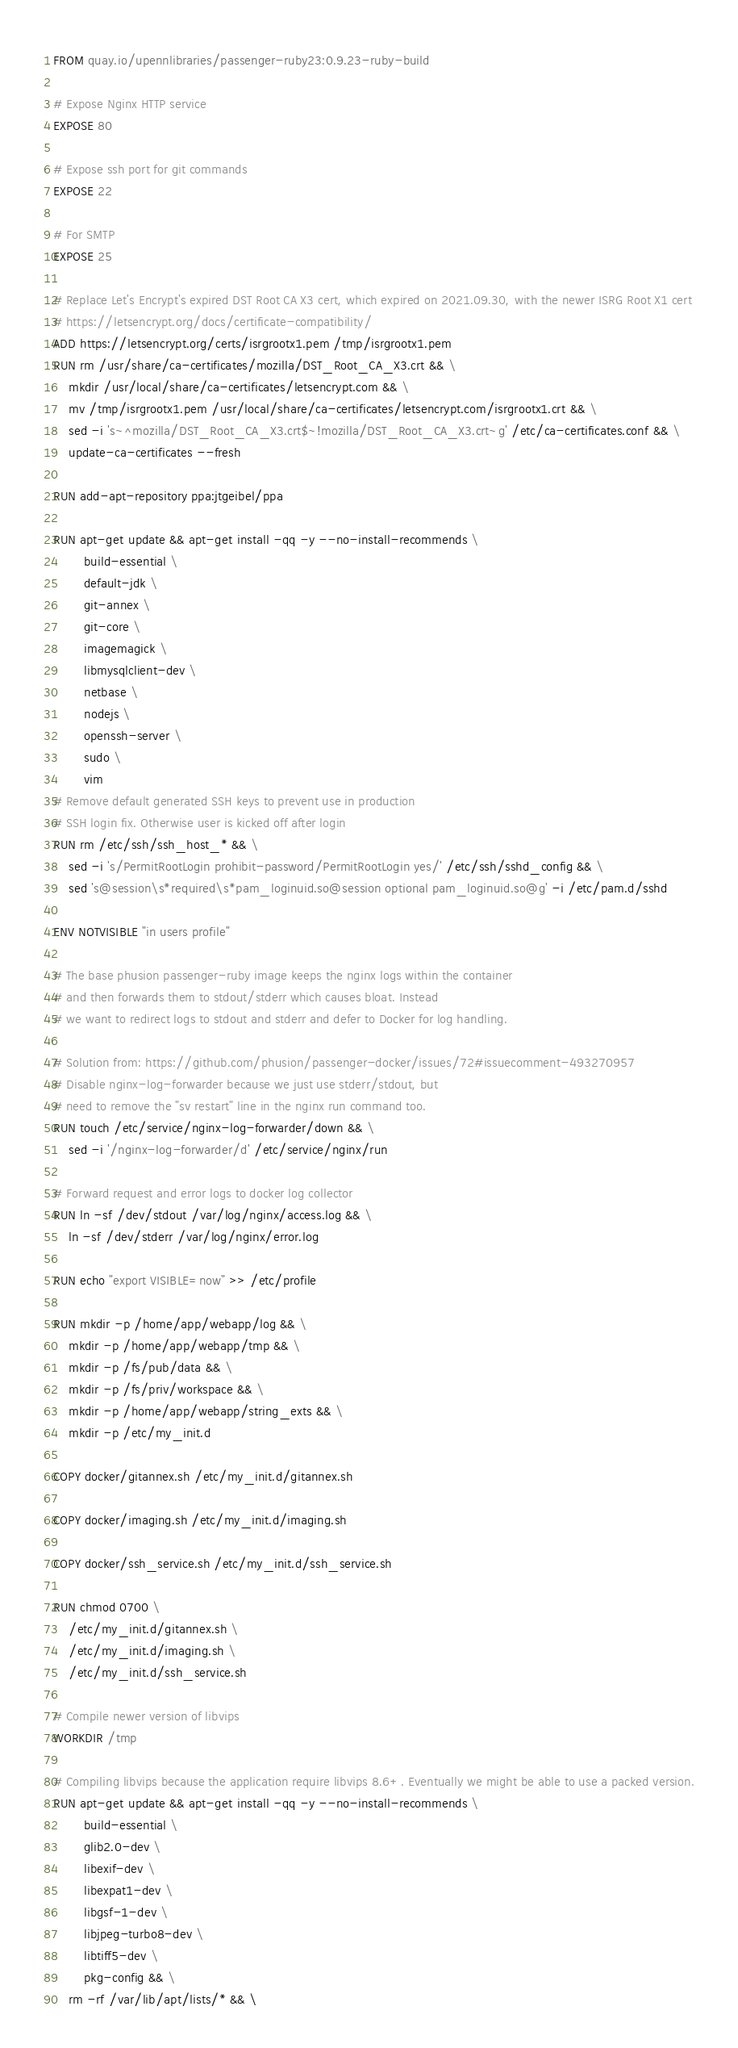Convert code to text. <code><loc_0><loc_0><loc_500><loc_500><_Dockerfile_>FROM quay.io/upennlibraries/passenger-ruby23:0.9.23-ruby-build

# Expose Nginx HTTP service
EXPOSE 80

# Expose ssh port for git commands
EXPOSE 22

# For SMTP
EXPOSE 25

# Replace Let's Encrypt's expired DST Root CA X3 cert, which expired on 2021.09.30, with the newer ISRG Root X1 cert
# https://letsencrypt.org/docs/certificate-compatibility/
ADD https://letsencrypt.org/certs/isrgrootx1.pem /tmp/isrgrootx1.pem
RUN rm /usr/share/ca-certificates/mozilla/DST_Root_CA_X3.crt && \
    mkdir /usr/local/share/ca-certificates/letsencrypt.com && \
    mv /tmp/isrgrootx1.pem /usr/local/share/ca-certificates/letsencrypt.com/isrgrootx1.crt && \
    sed -i 's~^mozilla/DST_Root_CA_X3.crt$~!mozilla/DST_Root_CA_X3.crt~g' /etc/ca-certificates.conf && \
    update-ca-certificates --fresh

RUN add-apt-repository ppa:jtgeibel/ppa

RUN apt-get update && apt-get install -qq -y --no-install-recommends \
        build-essential \
        default-jdk \
        git-annex \
        git-core \
        imagemagick \
        libmysqlclient-dev \
        netbase \
        nodejs \
        openssh-server \
        sudo \
        vim
# Remove default generated SSH keys to prevent use in production
# SSH login fix. Otherwise user is kicked off after login
RUN rm /etc/ssh/ssh_host_* && \
    sed -i 's/PermitRootLogin prohibit-password/PermitRootLogin yes/' /etc/ssh/sshd_config && \
    sed 's@session\s*required\s*pam_loginuid.so@session optional pam_loginuid.so@g' -i /etc/pam.d/sshd

ENV NOTVISIBLE "in users profile"

# The base phusion passenger-ruby image keeps the nginx logs within the container
# and then forwards them to stdout/stderr which causes bloat. Instead
# we want to redirect logs to stdout and stderr and defer to Docker for log handling.

# Solution from: https://github.com/phusion/passenger-docker/issues/72#issuecomment-493270957
# Disable nginx-log-forwarder because we just use stderr/stdout, but
# need to remove the "sv restart" line in the nginx run command too.
RUN touch /etc/service/nginx-log-forwarder/down && \
    sed -i '/nginx-log-forwarder/d' /etc/service/nginx/run

# Forward request and error logs to docker log collector
RUN ln -sf /dev/stdout /var/log/nginx/access.log && \
    ln -sf /dev/stderr /var/log/nginx/error.log

RUN echo "export VISIBLE=now" >> /etc/profile

RUN mkdir -p /home/app/webapp/log && \
    mkdir -p /home/app/webapp/tmp && \
    mkdir -p /fs/pub/data && \
    mkdir -p /fs/priv/workspace && \
    mkdir -p /home/app/webapp/string_exts && \
    mkdir -p /etc/my_init.d

COPY docker/gitannex.sh /etc/my_init.d/gitannex.sh

COPY docker/imaging.sh /etc/my_init.d/imaging.sh

COPY docker/ssh_service.sh /etc/my_init.d/ssh_service.sh

RUN chmod 0700 \
    /etc/my_init.d/gitannex.sh \
    /etc/my_init.d/imaging.sh \
    /etc/my_init.d/ssh_service.sh

# Compile newer version of libvips
WORKDIR /tmp

# Compiling libvips because the application require libvips 8.6+. Eventually we might be able to use a packed version.
RUN apt-get update && apt-get install -qq -y --no-install-recommends \
        build-essential \
        glib2.0-dev \
        libexif-dev \
        libexpat1-dev \
        libgsf-1-dev \
        libjpeg-turbo8-dev \
        libtiff5-dev \
        pkg-config && \
    rm -rf /var/lib/apt/lists/* && \</code> 